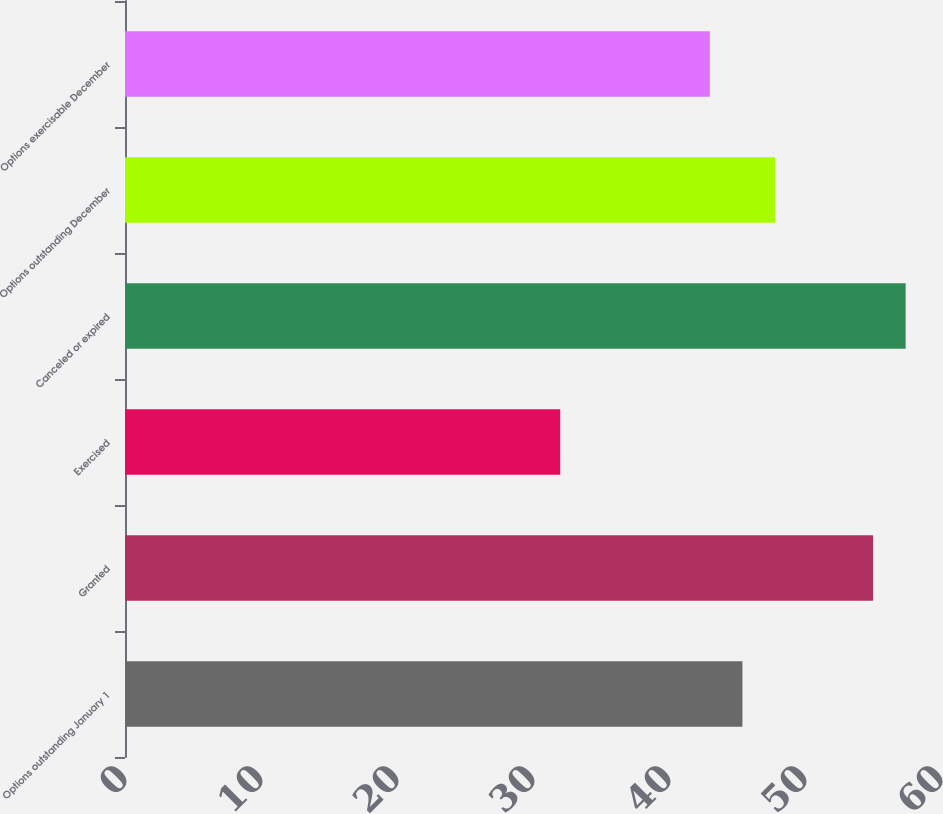Convert chart to OTSL. <chart><loc_0><loc_0><loc_500><loc_500><bar_chart><fcel>Options outstanding January 1<fcel>Granted<fcel>Exercised<fcel>Canceled or expired<fcel>Options outstanding December<fcel>Options exercisable December<nl><fcel>45.4<fcel>55<fcel>32<fcel>57.4<fcel>47.8<fcel>43<nl></chart> 